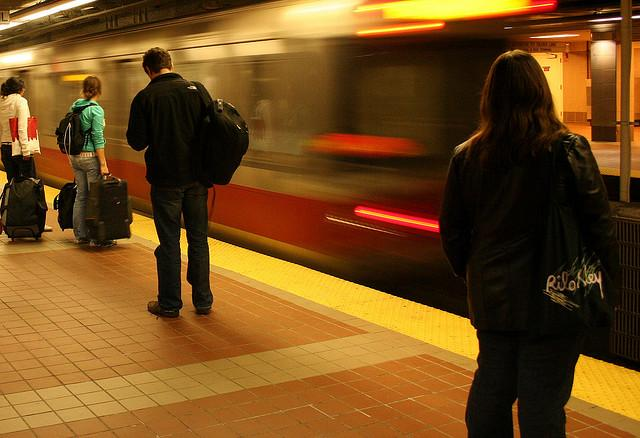What do the people do when the fast moving thing stops? Please explain your reasoning. board it. They have luggage and are standing near the track 